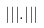<formula> <loc_0><loc_0><loc_500><loc_500>| | | . | | |</formula> 